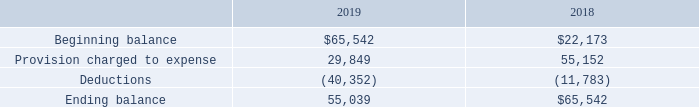Accounts Receivable
Accounts receivable are uncollateralized customer obligations due under normal trade terms. The Company records allowances for doubtful accounts based on customer-specific analysis and general matters such as current assessment of past due balances and economic conditions. The Company writes off accounts receivable when they become uncollectible. The allowance for doubtful accounts was $55,039 and $65,542 at December 31, 2019 and 2018, respectively. Management identifies a delinquent customer based upon the delinquent payment status of an outstanding invoice, generally greater than 30 days past due date. The delinquent account designation does not trigger an accounting transaction until such time the account is deemed uncollectible. The allowance for doubtful accounts is determined by examining the reserve history and any outstanding invoices that are over 30 days past due as of the end of the reporting period. Accounts are deemed uncollectible on a case-by-case basis, at management’s discretion based upon an examination of the communication with the delinquent customer and payment history. Typically, accounts are only escalated to “uncollectible” status after multiple attempts at collection have proven unsuccessful.
The allowance for doubtful accounts for the years ended December 31 are as follows:
What is the allowance for doubtful accounts at December 31, 2019? $55,039. When are accounts receivable written off? When they become uncollectible. When are accounts escalated to "uncollectible" status? After multiple attempts at collection have proven unsuccessful. Which year has the higher deductions? Compare the deduction value between the two years, find the year with the higher deductions value
Answer: 2019. What is the percentage change in the ending balance of allowance for doubtful accounts from 2018 to 2019?
Answer scale should be: percent. (55,039-65,542)/65,542
Answer: -16.02. What is the change in beginning balance of allowance of doubtful accounts from 2018 to 2019? 65,542-22,173
Answer: 43369. 